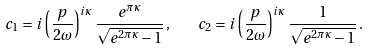<formula> <loc_0><loc_0><loc_500><loc_500>c _ { 1 } = i \left ( \frac { p } { 2 \omega } \right ) ^ { i \kappa } \frac { e ^ { \pi \kappa } } { \sqrt { e ^ { 2 \pi \kappa } - 1 } } \, , \quad c _ { 2 } = i \left ( \frac { p } { 2 \omega } \right ) ^ { i \kappa } \frac { 1 } { \sqrt { e ^ { 2 \pi \kappa } - 1 } } \, .</formula> 